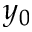Convert formula to latex. <formula><loc_0><loc_0><loc_500><loc_500>y _ { 0 }</formula> 